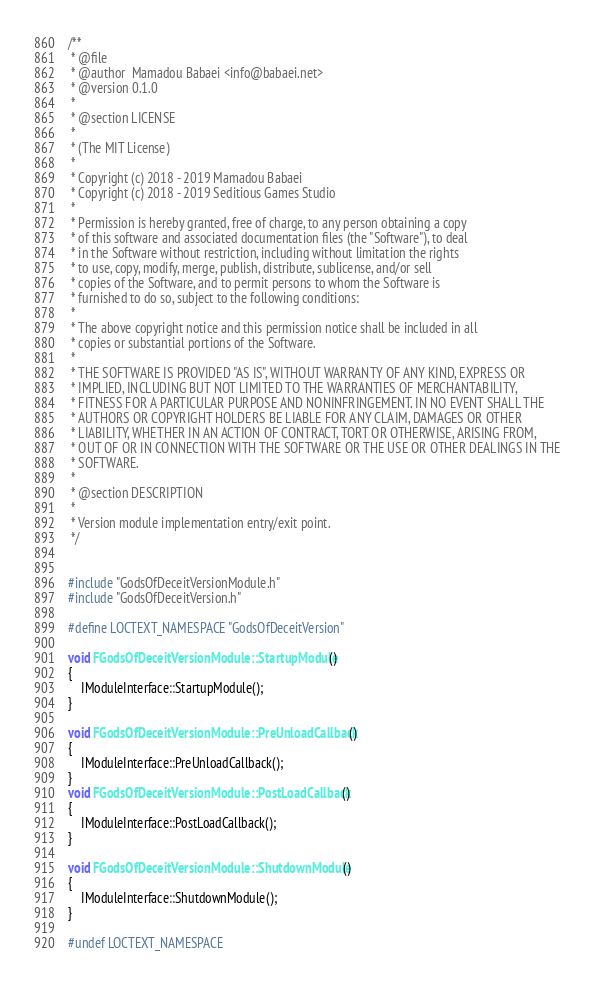<code> <loc_0><loc_0><loc_500><loc_500><_C++_>/**
 * @file
 * @author  Mamadou Babaei <info@babaei.net>
 * @version 0.1.0
 *
 * @section LICENSE
 *
 * (The MIT License)
 *
 * Copyright (c) 2018 - 2019 Mamadou Babaei
 * Copyright (c) 2018 - 2019 Seditious Games Studio
 *
 * Permission is hereby granted, free of charge, to any person obtaining a copy
 * of this software and associated documentation files (the "Software"), to deal
 * in the Software without restriction, including without limitation the rights
 * to use, copy, modify, merge, publish, distribute, sublicense, and/or sell
 * copies of the Software, and to permit persons to whom the Software is
 * furnished to do so, subject to the following conditions:
 *
 * The above copyright notice and this permission notice shall be included in all
 * copies or substantial portions of the Software.
 *
 * THE SOFTWARE IS PROVIDED "AS IS", WITHOUT WARRANTY OF ANY KIND, EXPRESS OR
 * IMPLIED, INCLUDING BUT NOT LIMITED TO THE WARRANTIES OF MERCHANTABILITY,
 * FITNESS FOR A PARTICULAR PURPOSE AND NONINFRINGEMENT. IN NO EVENT SHALL THE
 * AUTHORS OR COPYRIGHT HOLDERS BE LIABLE FOR ANY CLAIM, DAMAGES OR OTHER
 * LIABILITY, WHETHER IN AN ACTION OF CONTRACT, TORT OR OTHERWISE, ARISING FROM,
 * OUT OF OR IN CONNECTION WITH THE SOFTWARE OR THE USE OR OTHER DEALINGS IN THE
 * SOFTWARE.
 *
 * @section DESCRIPTION
 *
 * Version module implementation entry/exit point.
 */


#include "GodsOfDeceitVersionModule.h"
#include "GodsOfDeceitVersion.h"

#define LOCTEXT_NAMESPACE "GodsOfDeceitVersion"

void FGodsOfDeceitVersionModule::StartupModule()
{
    IModuleInterface::StartupModule();
}

void FGodsOfDeceitVersionModule::PreUnloadCallback()
{
    IModuleInterface::PreUnloadCallback();
}
void FGodsOfDeceitVersionModule::PostLoadCallback()
{
    IModuleInterface::PostLoadCallback();
}

void FGodsOfDeceitVersionModule::ShutdownModule()
{
    IModuleInterface::ShutdownModule();
}

#undef LOCTEXT_NAMESPACE
</code> 